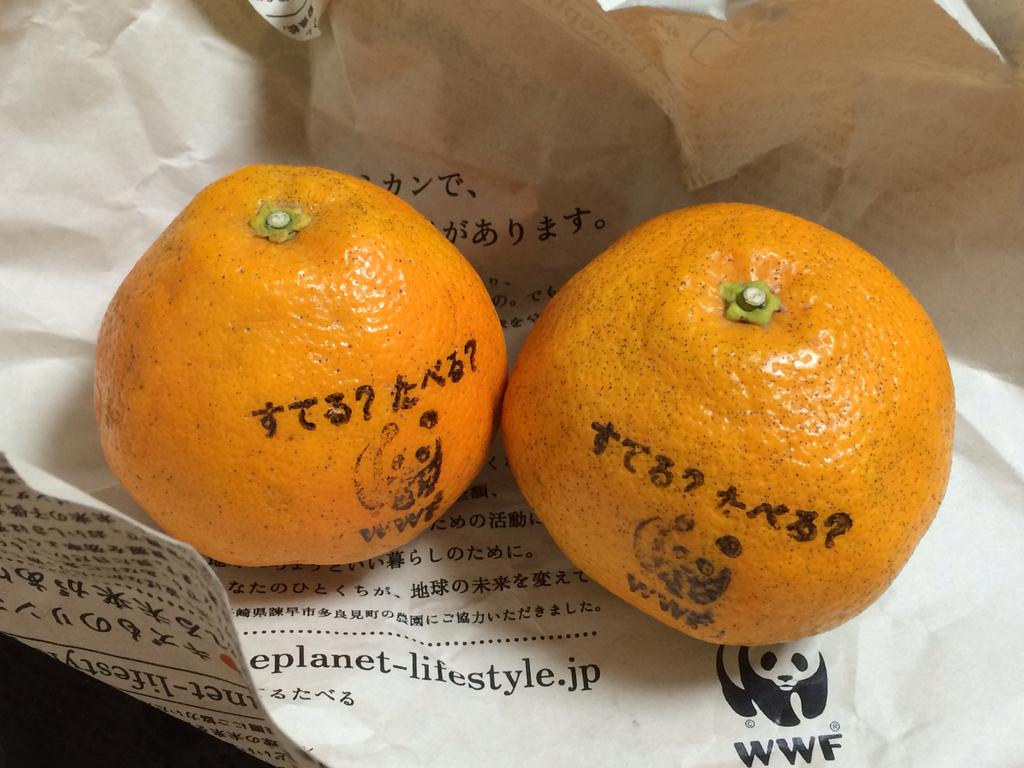What type of fruit is present in the image? There are two oranges in the image. How are the oranges arranged in the image? The oranges are placed beside each other. What surface are the oranges resting on? The oranges are on a paper. Is there any text or writing on the paper? Yes, there is some script on the paper. Can you tell me how many gravestones are visible in the cemetery in the image? There is no cemetery or gravestones present in the image; it features two oranges on a paper with some script. What type of farm animals can be seen grazing in the image? There are no farm animals present in the image; it features two oranges on a paper with some script. 